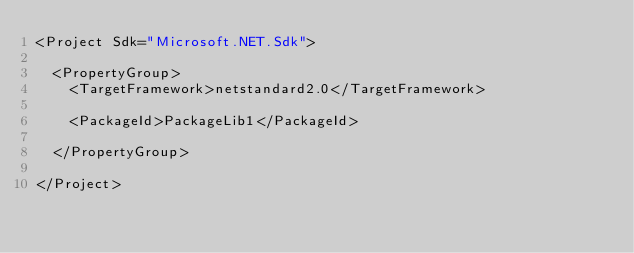Convert code to text. <code><loc_0><loc_0><loc_500><loc_500><_XML_><Project Sdk="Microsoft.NET.Sdk">

  <PropertyGroup>
    <TargetFramework>netstandard2.0</TargetFramework>

    <PackageId>PackageLib1</PackageId>
    
  </PropertyGroup>

</Project>
</code> 